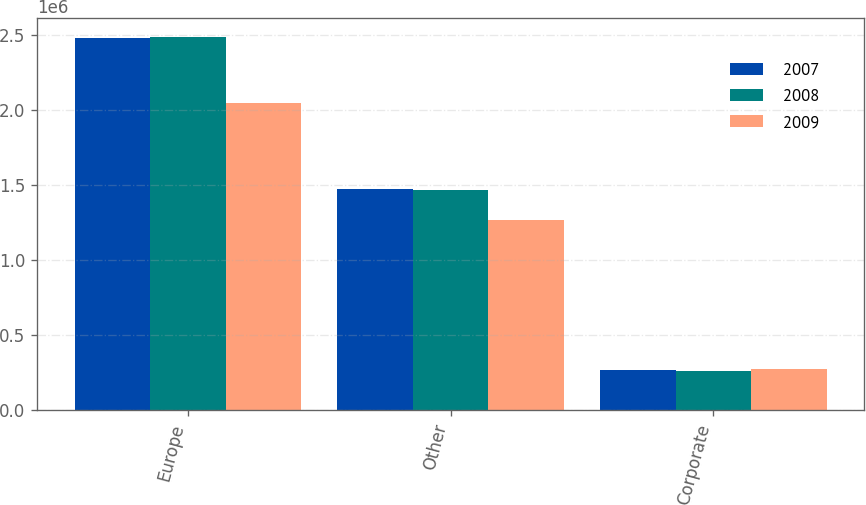Convert chart to OTSL. <chart><loc_0><loc_0><loc_500><loc_500><stacked_bar_chart><ecel><fcel>Europe<fcel>Other<fcel>Corporate<nl><fcel>2007<fcel>2.47825e+06<fcel>1.47794e+06<fcel>268592<nl><fcel>2008<fcel>2.48896e+06<fcel>1.4693e+06<fcel>261990<nl><fcel>2009<fcel>2.04739e+06<fcel>1.26596e+06<fcel>274000<nl></chart> 